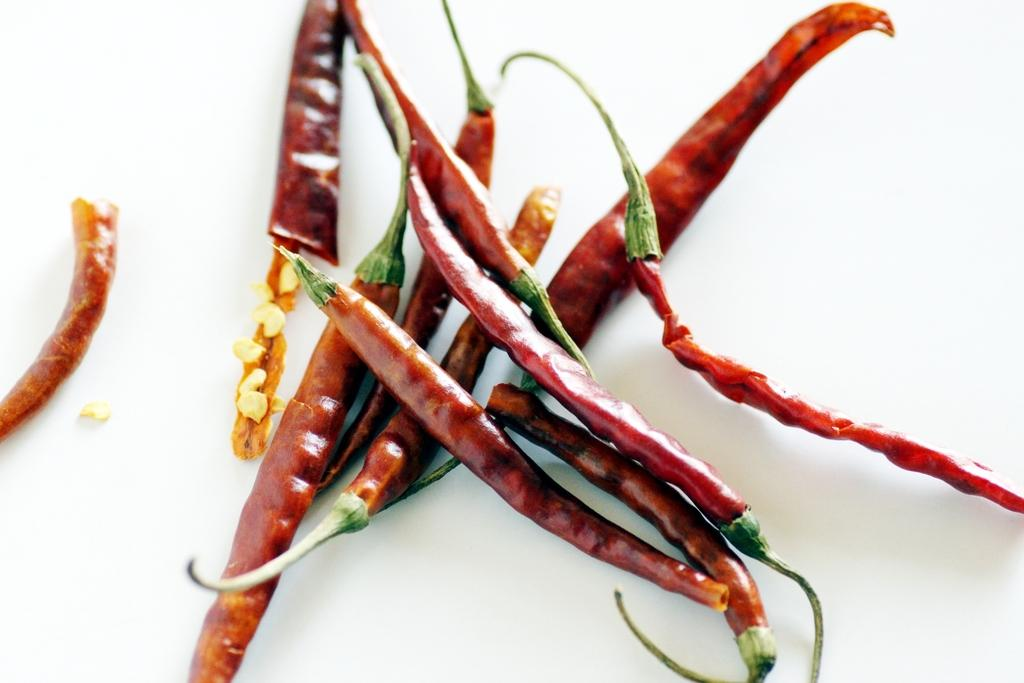What type of food items are present in the image? There are chilis in the image. Can you describe the appearance of the chilis? The chilis in the image are likely red or green, as these are the most common colors for chilis. What might be a common use for chilis in cooking? Chilis are often used to add spice or heat to dishes. How does the boy behave when he sees the apple in the image? There is no boy or apple present in the image, so it is not possible to answer that question. 